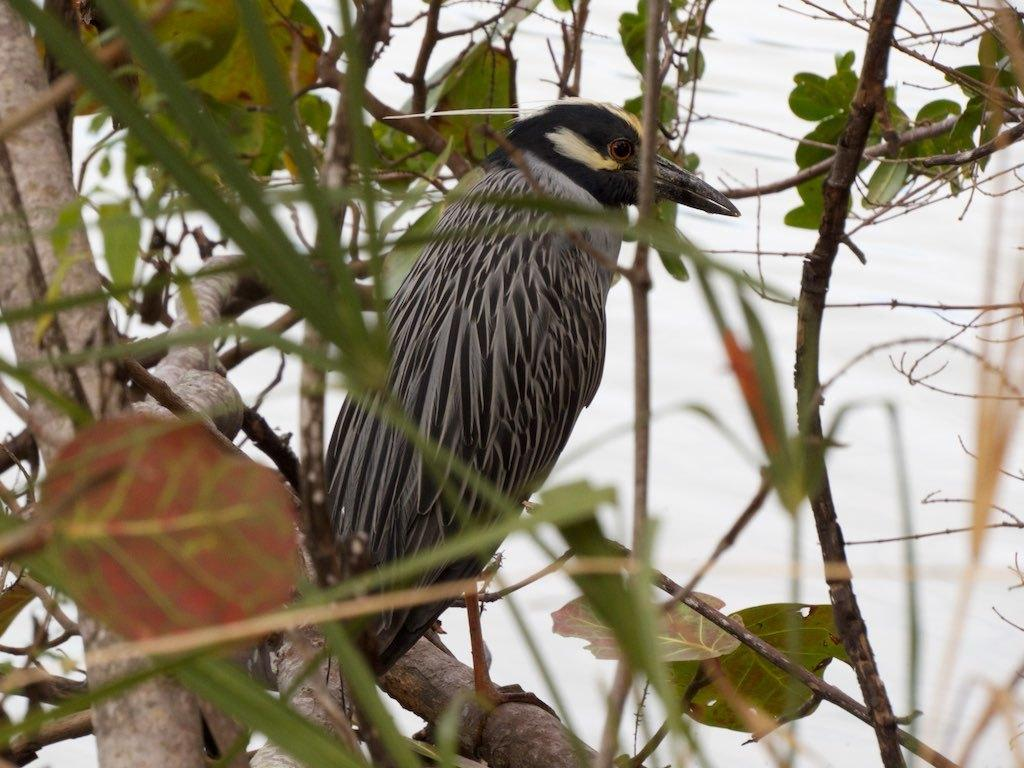What is the main subject of the image? There is a bird on a tree in the center of the image. Can you describe the bird's location in the image? The bird is on a tree in the center of the image. What else can be seen in the background of the image? There are trees visible in the background of the image. How many balls can be seen in the image? There are no balls present in the image. Is the bird in the image a pet? The image does not provide information about whether the bird is a pet or not. 